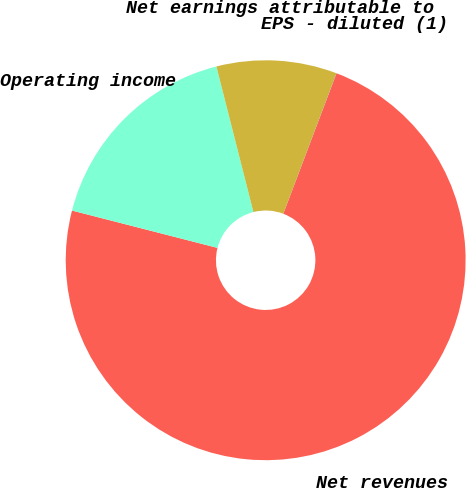Convert chart to OTSL. <chart><loc_0><loc_0><loc_500><loc_500><pie_chart><fcel>Net revenues<fcel>Operating income<fcel>Net earnings attributable to<fcel>EPS - diluted (1)<nl><fcel>73.23%<fcel>17.04%<fcel>9.72%<fcel>0.01%<nl></chart> 